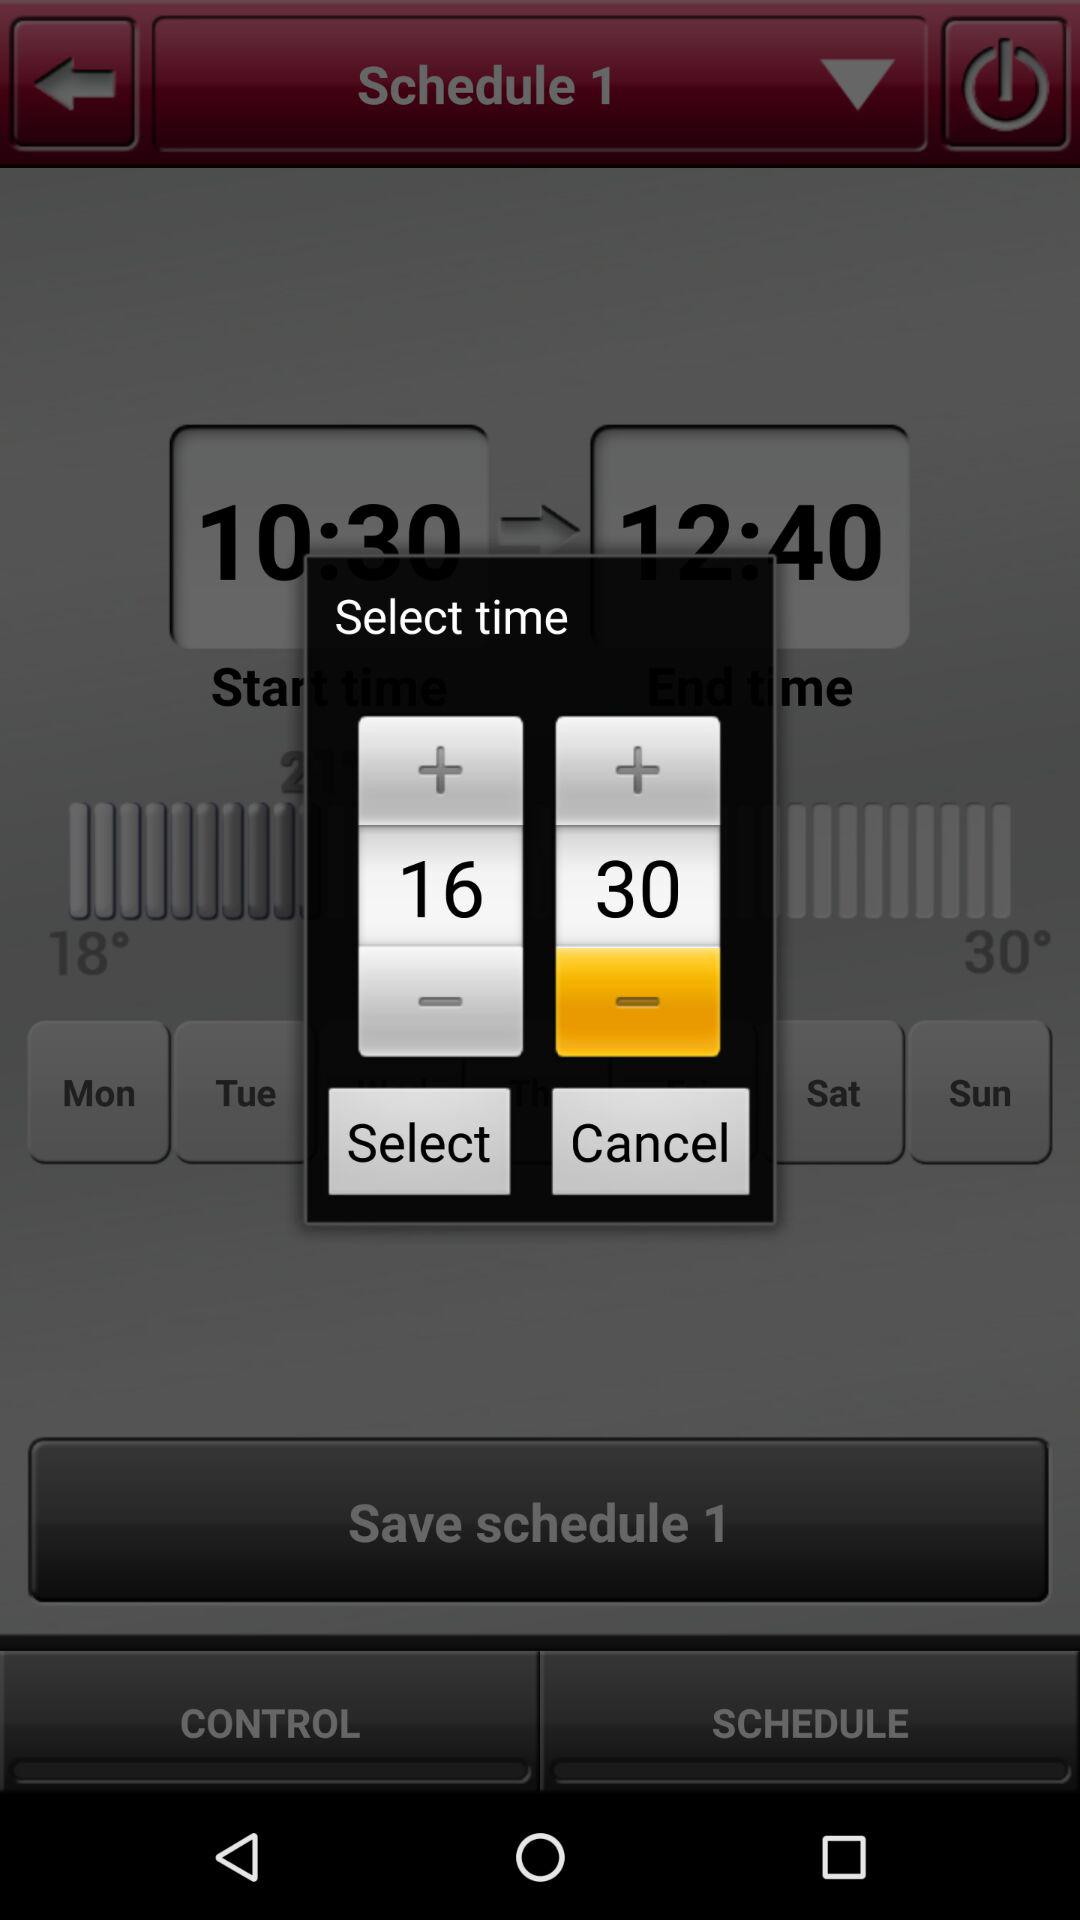How many more minutes are in the second time slot than the first?
Answer the question using a single word or phrase. 14 